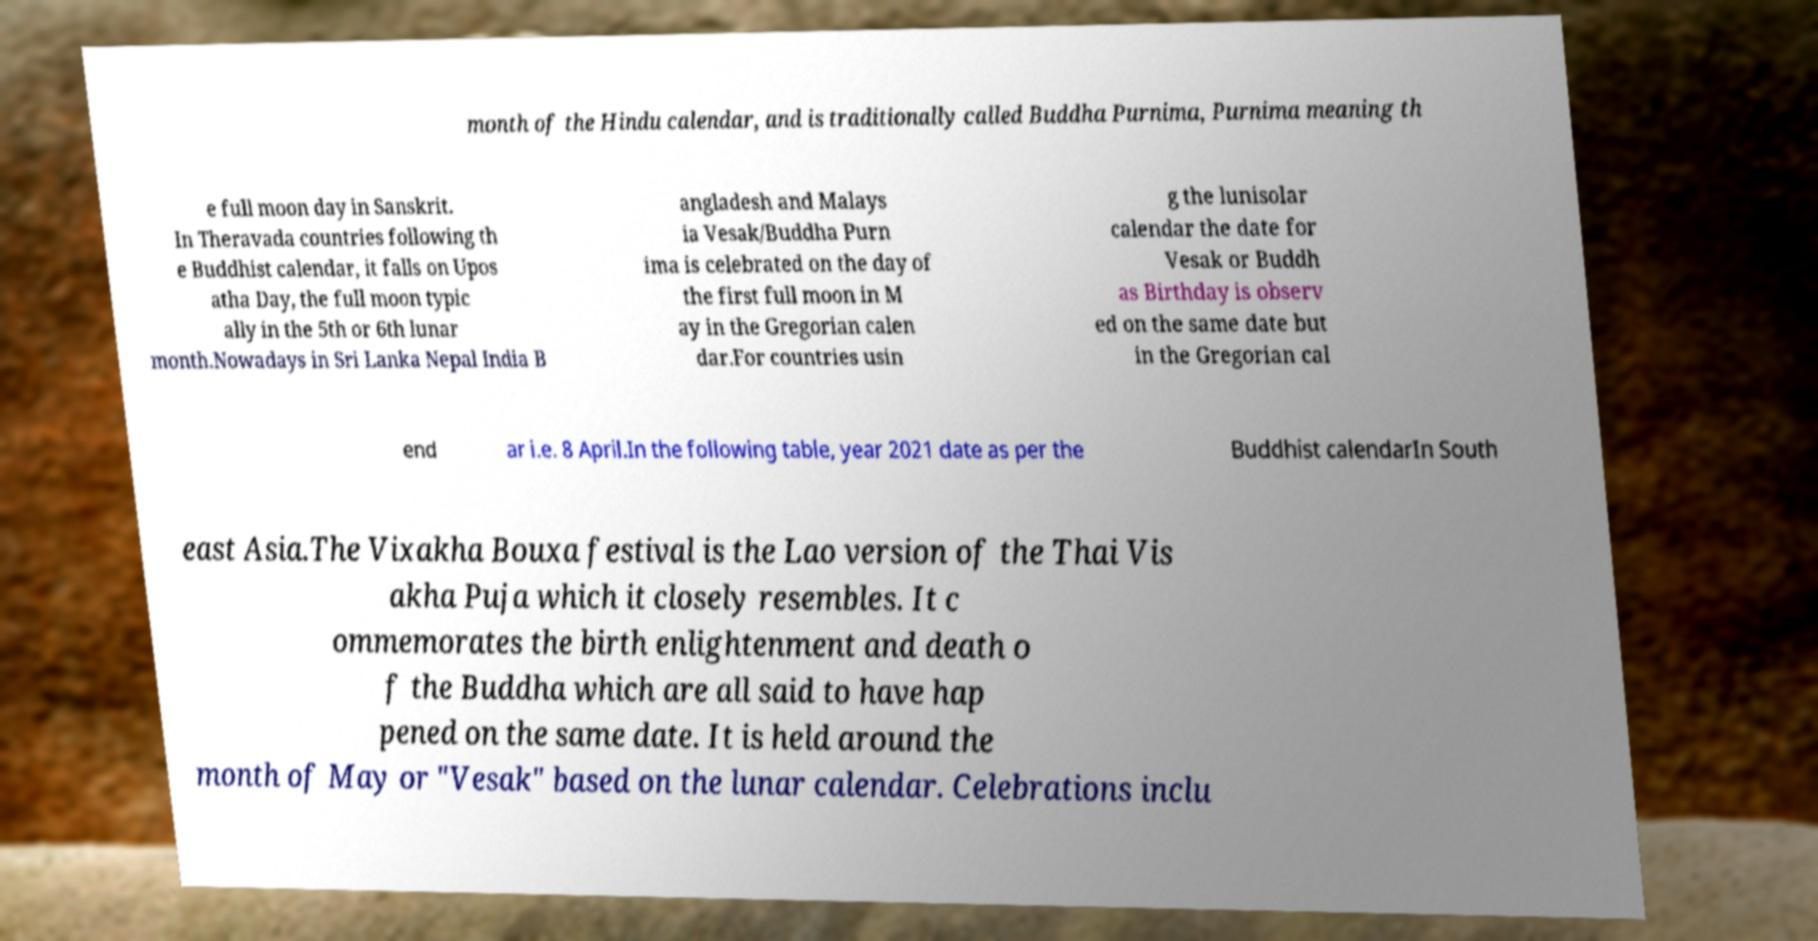For documentation purposes, I need the text within this image transcribed. Could you provide that? month of the Hindu calendar, and is traditionally called Buddha Purnima, Purnima meaning th e full moon day in Sanskrit. In Theravada countries following th e Buddhist calendar, it falls on Upos atha Day, the full moon typic ally in the 5th or 6th lunar month.Nowadays in Sri Lanka Nepal India B angladesh and Malays ia Vesak/Buddha Purn ima is celebrated on the day of the first full moon in M ay in the Gregorian calen dar.For countries usin g the lunisolar calendar the date for Vesak or Buddh as Birthday is observ ed on the same date but in the Gregorian cal end ar i.e. 8 April.In the following table, year 2021 date as per the Buddhist calendarIn South east Asia.The Vixakha Bouxa festival is the Lao version of the Thai Vis akha Puja which it closely resembles. It c ommemorates the birth enlightenment and death o f the Buddha which are all said to have hap pened on the same date. It is held around the month of May or "Vesak" based on the lunar calendar. Celebrations inclu 